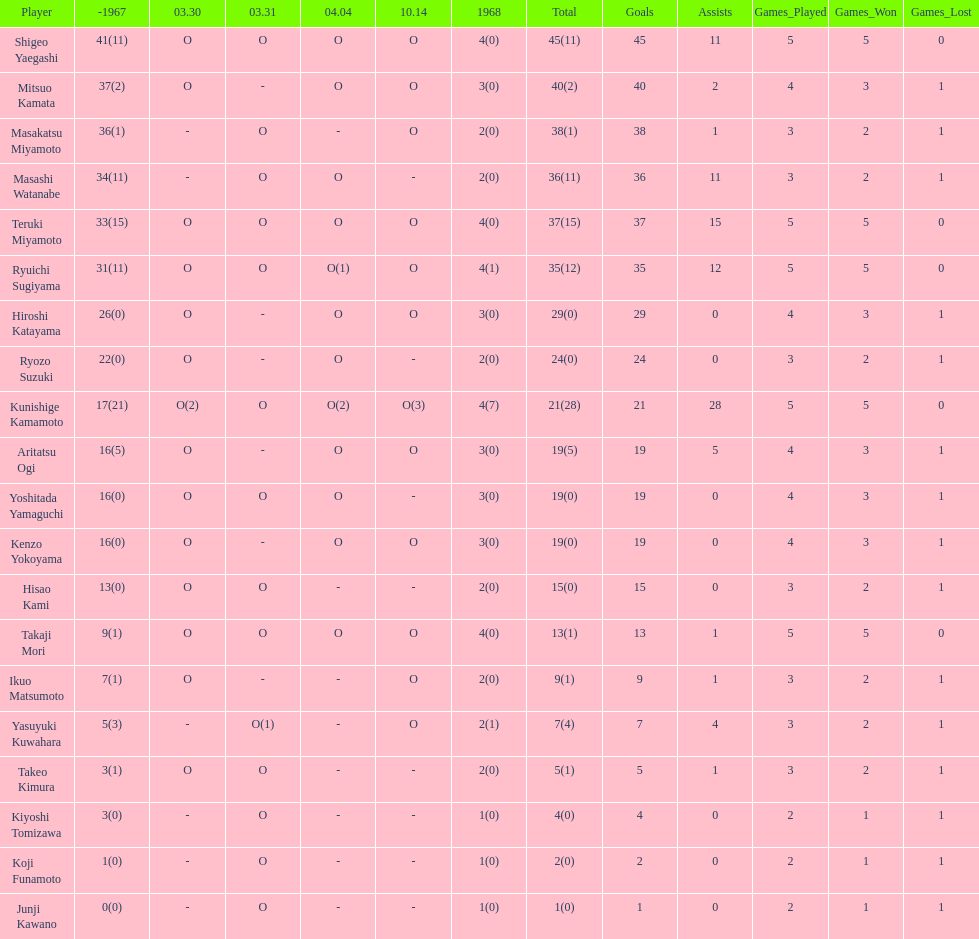How many more total appearances did shigeo yaegashi have than mitsuo kamata? 5. 